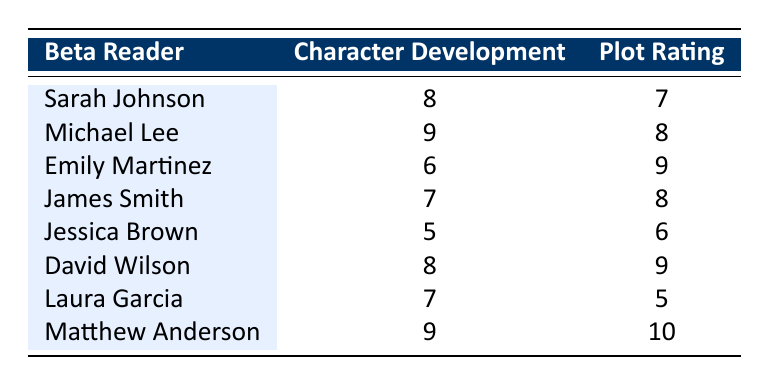What is the highest character development rating from the beta readers? Matthew Anderson has the highest character development rating of 9, as shown in the table.
Answer: 9 What is the lowest plot rating given by a beta reader? Jessica Brown has the lowest plot rating of 6, which can be seen in the table.
Answer: 6 Who provided the most positive feedback on both character development and plot? Matthew Anderson rated both character development (9) and plot (10) the highest among the readers, indicating the most positive feedback.
Answer: Matthew Anderson What is the average character development rating across all beta readers? To find the average, add all the ratings (8 + 9 + 6 + 7 + 5 + 8 + 7 + 9) which equals 59. There are 8 readers, so the average is 59 / 8 = 7.375.
Answer: 7.375 Did any reader rate the plot higher than the character development? Yes, Emily Martinez rated the plot 9 while giving character development a rating of 6, indicating that her plot rating was higher than her character development rating.
Answer: Yes Which beta reader had the greatest difference between their character development and plot ratings? Matthew Anderson had a difference of 1 (9 - 10 = -1), while others like Jessica Brown had a difference of 1 as well (5 - 6 = -1). This indicates the least difference. However, David Wilson had a larger difference of 1 (8 - 9 = -1). The greatest difference by absolute value would be Emily Martinez (6 vs. 9, a difference of 3).
Answer: Emily Martinez What percentage of the beta readers rated character development 7 or higher? There are 5 readers (Sarah Johnson, Michael Lee, David Wilson, Laura Garcia, and Matthew Anderson) who rated character development 7 or higher out of 8 total readers. So, (5/8)*100 = 62.5%.
Answer: 62.5% Is there a reader who rated both character development and plot the same? No, all ratings for character development and plot are different among the beta readers according to the table data.
Answer: No What is the total rating for character development from all beta readers? The total rating can be found by summing the character development ratings: 8 + 9 + 6 + 7 + 5 + 8 + 7 + 9 = 59.
Answer: 59 